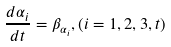Convert formula to latex. <formula><loc_0><loc_0><loc_500><loc_500>\frac { d \alpha _ { i } } { d t } = \beta _ { \alpha _ { i } } , ( i = 1 , 2 , 3 , t )</formula> 